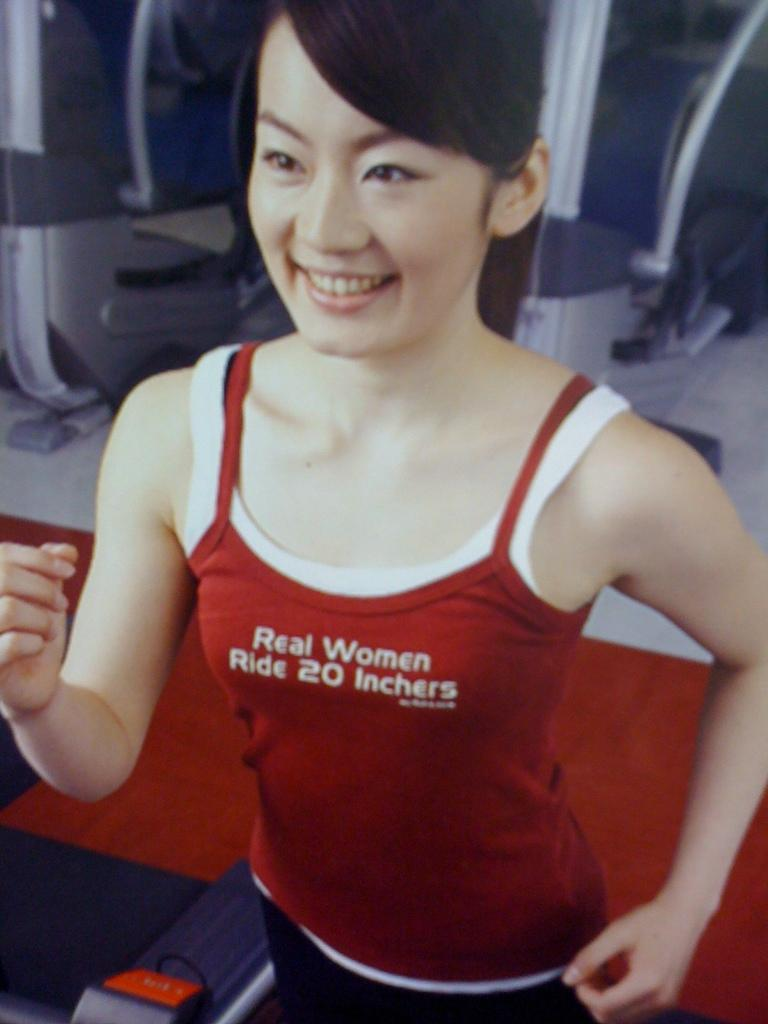Provide a one-sentence caption for the provided image. A woman exercising with a tank top on that says Real Women Ride 20 Inchers. 